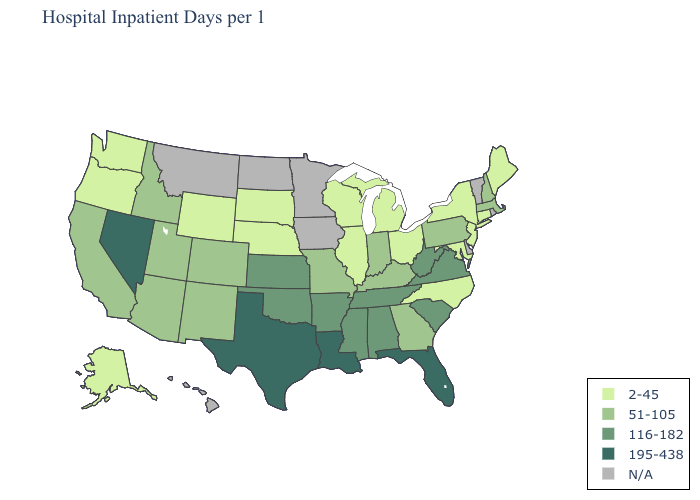What is the lowest value in the Northeast?
Concise answer only. 2-45. What is the value of Louisiana?
Write a very short answer. 195-438. Which states have the lowest value in the Northeast?
Write a very short answer. Connecticut, Maine, New Jersey, New York. What is the lowest value in the Northeast?
Quick response, please. 2-45. What is the highest value in the West ?
Give a very brief answer. 195-438. How many symbols are there in the legend?
Quick response, please. 5. Which states have the highest value in the USA?
Quick response, please. Florida, Louisiana, Nevada, Texas. What is the highest value in the Northeast ?
Be succinct. 51-105. What is the value of Washington?
Keep it brief. 2-45. Name the states that have a value in the range 51-105?
Keep it brief. Arizona, California, Colorado, Georgia, Idaho, Indiana, Kentucky, Massachusetts, Missouri, New Hampshire, New Mexico, Pennsylvania, Utah. Does Maryland have the lowest value in the South?
Concise answer only. Yes. Name the states that have a value in the range 195-438?
Short answer required. Florida, Louisiana, Nevada, Texas. What is the lowest value in the Northeast?
Answer briefly. 2-45. What is the value of Ohio?
Be succinct. 2-45. 